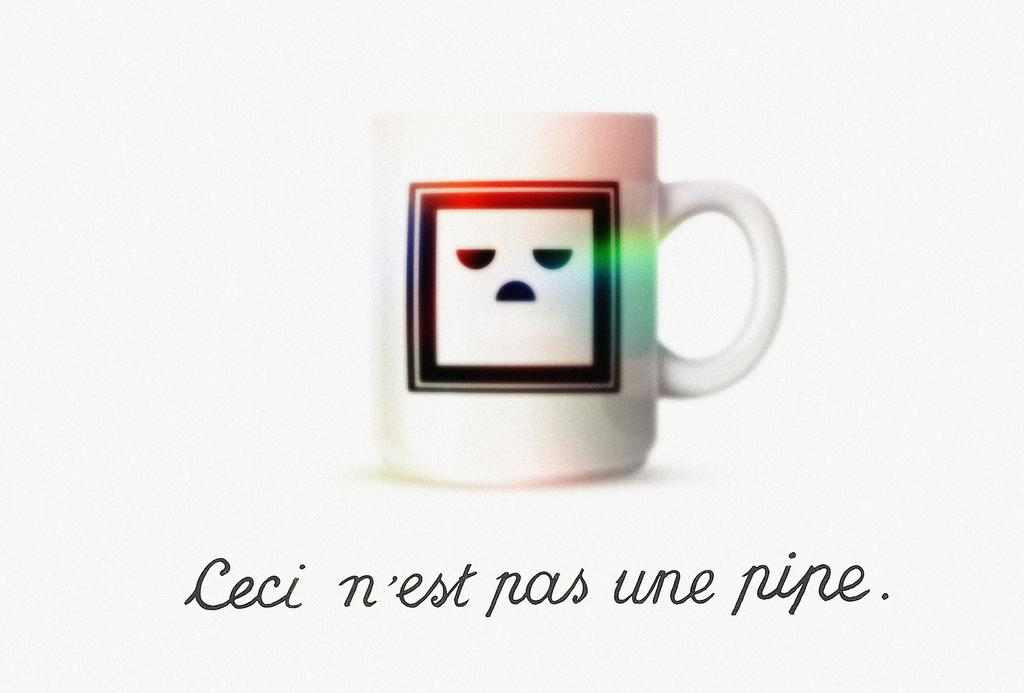<image>
Write a terse but informative summary of the picture. a cup with the word pipe in the bottom right 